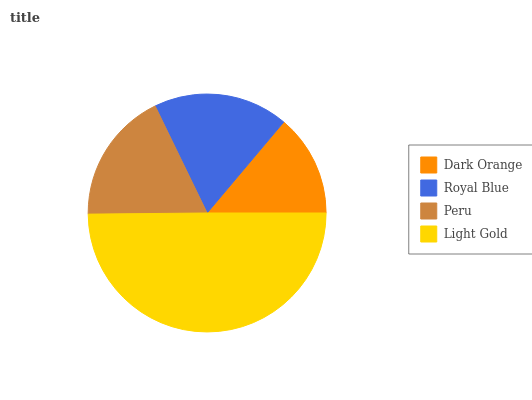Is Dark Orange the minimum?
Answer yes or no. Yes. Is Light Gold the maximum?
Answer yes or no. Yes. Is Royal Blue the minimum?
Answer yes or no. No. Is Royal Blue the maximum?
Answer yes or no. No. Is Royal Blue greater than Dark Orange?
Answer yes or no. Yes. Is Dark Orange less than Royal Blue?
Answer yes or no. Yes. Is Dark Orange greater than Royal Blue?
Answer yes or no. No. Is Royal Blue less than Dark Orange?
Answer yes or no. No. Is Royal Blue the high median?
Answer yes or no. Yes. Is Peru the low median?
Answer yes or no. Yes. Is Peru the high median?
Answer yes or no. No. Is Dark Orange the low median?
Answer yes or no. No. 